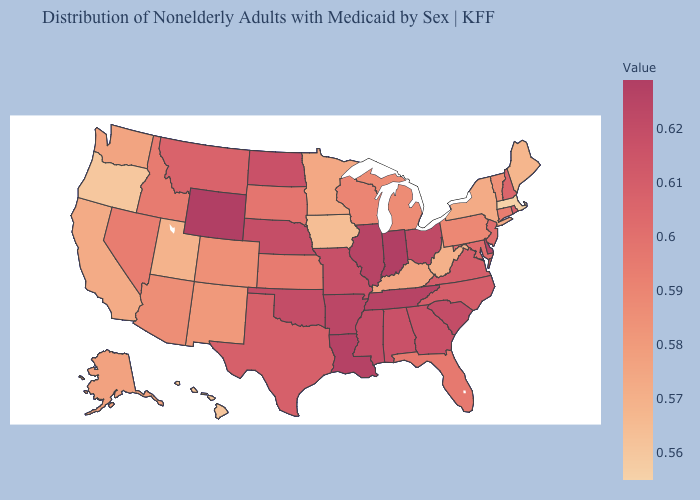Among the states that border Nebraska , does Iowa have the lowest value?
Keep it brief. Yes. 